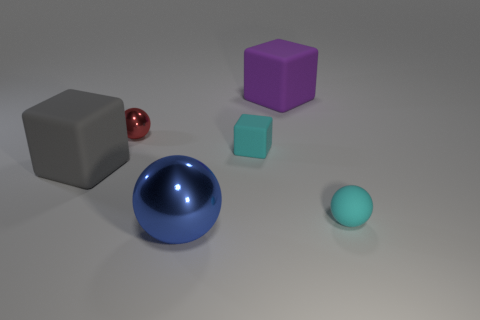Are there any small rubber spheres of the same color as the small cube?
Offer a very short reply. Yes. There is a small object that is the same color as the tiny matte ball; what is it made of?
Make the answer very short. Rubber. What is the color of the thing that is both behind the cyan cube and on the right side of the blue thing?
Offer a terse response. Purple. What number of other objects are there of the same shape as the tiny metallic thing?
Offer a very short reply. 2. Is the number of tiny things in front of the tiny matte sphere less than the number of large gray blocks that are behind the tiny metal sphere?
Offer a very short reply. No. Is the cyan sphere made of the same material as the object behind the red thing?
Your answer should be compact. Yes. Is the number of small cyan balls greater than the number of things?
Provide a succinct answer. No. The purple rubber thing that is behind the block that is in front of the tiny cyan matte thing on the left side of the rubber ball is what shape?
Make the answer very short. Cube. Is the thing that is to the right of the purple object made of the same material as the cyan thing to the left of the matte sphere?
Offer a terse response. Yes. There is a purple object that is made of the same material as the cyan ball; what shape is it?
Provide a succinct answer. Cube. 